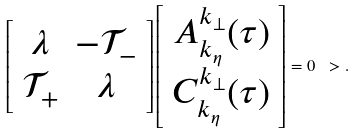Convert formula to latex. <formula><loc_0><loc_0><loc_500><loc_500>\left [ \begin{array} { c c } \lambda & - \mathcal { T } _ { - } \\ \mathcal { T } _ { + } & \lambda \end{array} \right ] \left [ \begin{array} { r } A ^ { k _ { \perp } } _ { k _ { \eta } } ( \tau ) \\ C ^ { k _ { \perp } } _ { k _ { \eta } } ( \tau ) \end{array} \right ] = 0 \ > .</formula> 